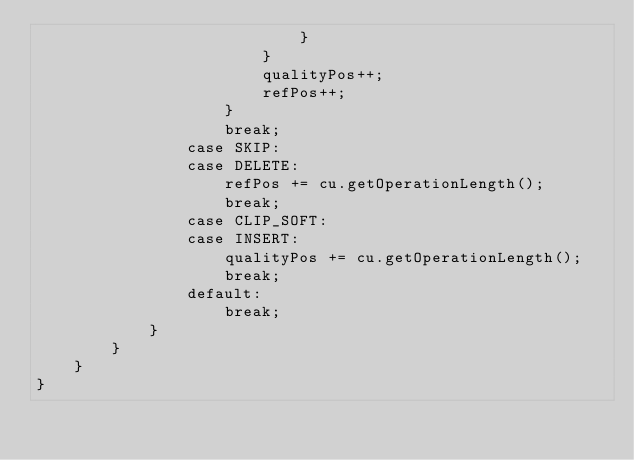<code> <loc_0><loc_0><loc_500><loc_500><_Java_>                            }
                        }
                        qualityPos++;
                        refPos++;
                    }
                    break;
                case SKIP:
                case DELETE:
                    refPos += cu.getOperationLength();
                    break;
                case CLIP_SOFT:
                case INSERT:
                    qualityPos += cu.getOperationLength();
                    break;
                default:
                    break;
            }
        }
    }
}
</code> 